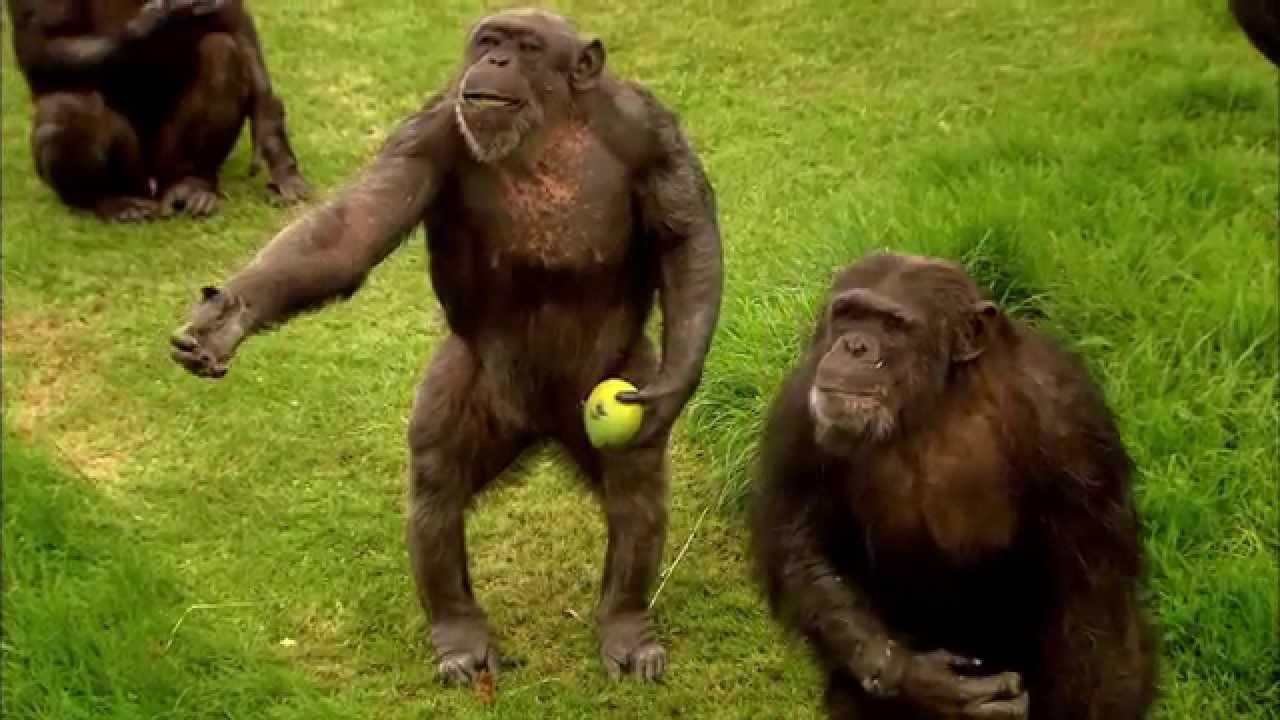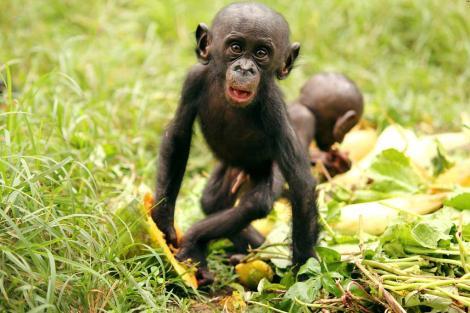The first image is the image on the left, the second image is the image on the right. For the images displayed, is the sentence "There is exactly one monkey in the image on the left." factually correct? Answer yes or no. No. The first image is the image on the left, the second image is the image on the right. Examine the images to the left and right. Is the description "Two chimps of the same approximate size and age are present in the right image." accurate? Answer yes or no. Yes. 